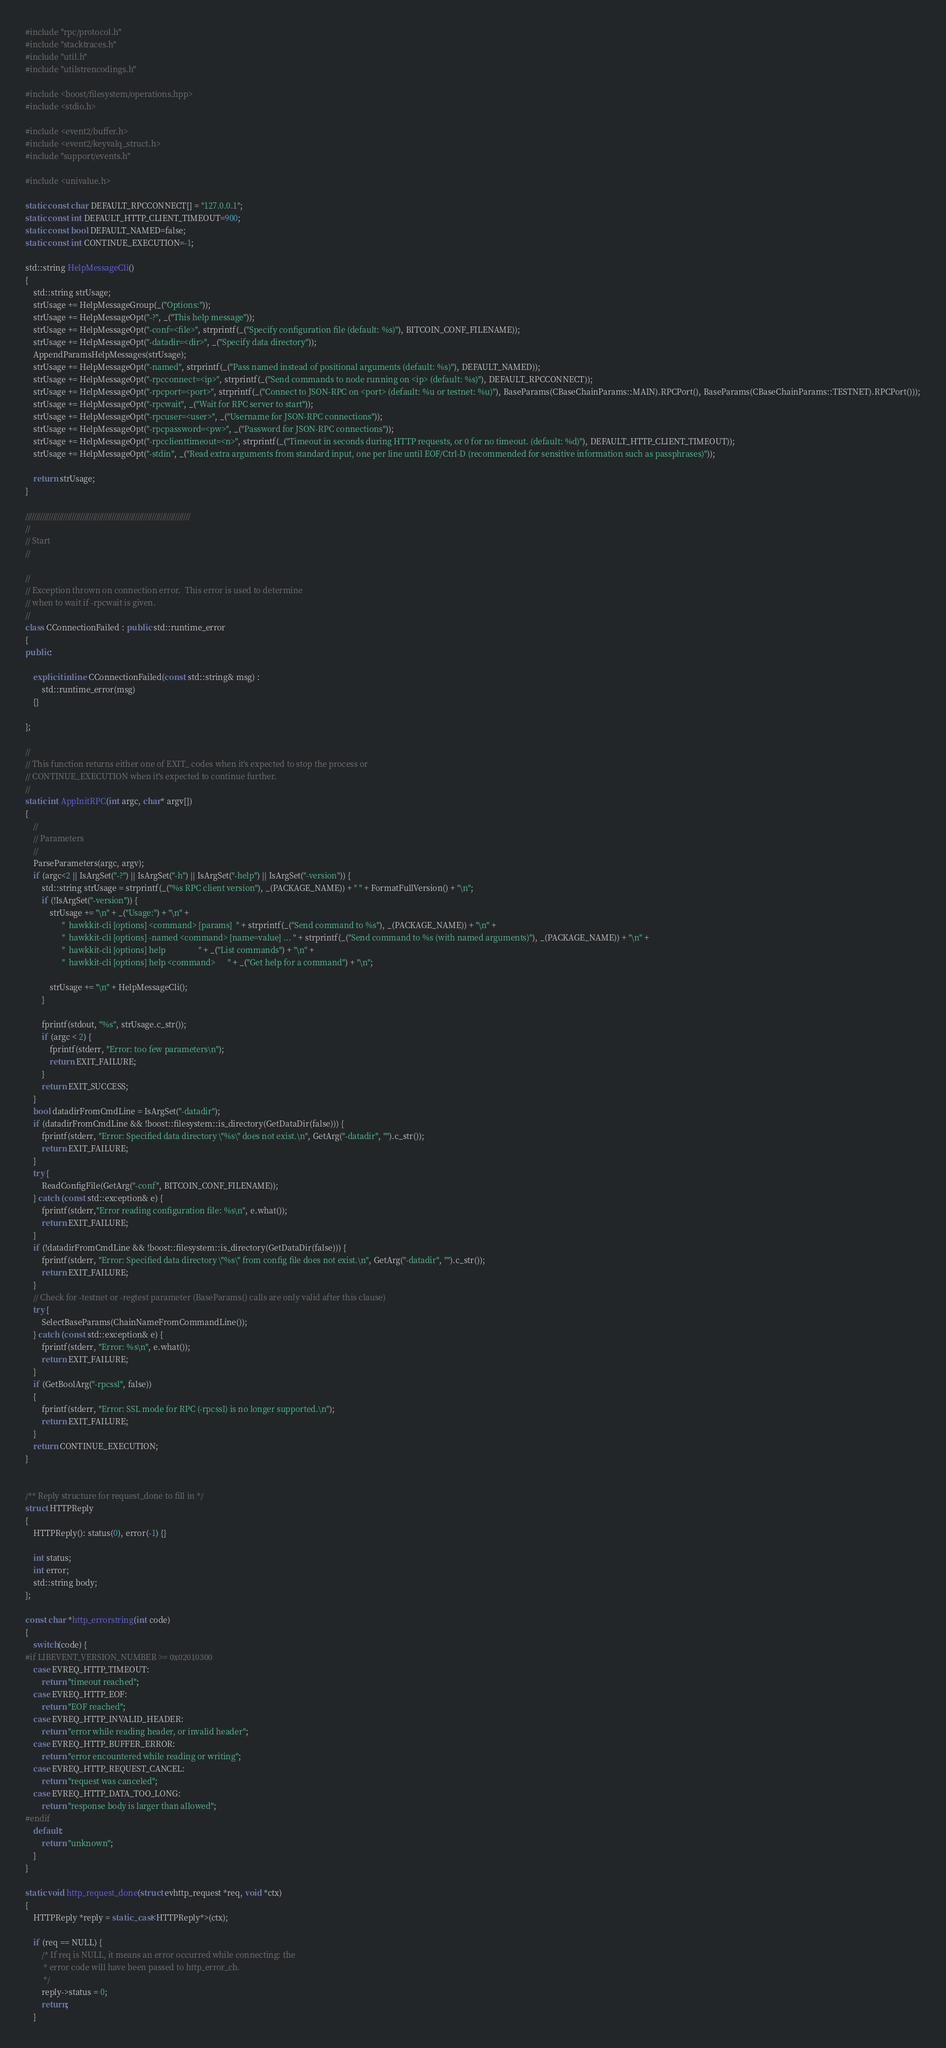<code> <loc_0><loc_0><loc_500><loc_500><_C++_>#include "rpc/protocol.h"
#include "stacktraces.h"
#include "util.h"
#include "utilstrencodings.h"

#include <boost/filesystem/operations.hpp>
#include <stdio.h>

#include <event2/buffer.h>
#include <event2/keyvalq_struct.h>
#include "support/events.h"

#include <univalue.h>

static const char DEFAULT_RPCCONNECT[] = "127.0.0.1";
static const int DEFAULT_HTTP_CLIENT_TIMEOUT=900;
static const bool DEFAULT_NAMED=false;
static const int CONTINUE_EXECUTION=-1;

std::string HelpMessageCli()
{
    std::string strUsage;
    strUsage += HelpMessageGroup(_("Options:"));
    strUsage += HelpMessageOpt("-?", _("This help message"));
    strUsage += HelpMessageOpt("-conf=<file>", strprintf(_("Specify configuration file (default: %s)"), BITCOIN_CONF_FILENAME));
    strUsage += HelpMessageOpt("-datadir=<dir>", _("Specify data directory"));
    AppendParamsHelpMessages(strUsage);
    strUsage += HelpMessageOpt("-named", strprintf(_("Pass named instead of positional arguments (default: %s)"), DEFAULT_NAMED));
    strUsage += HelpMessageOpt("-rpcconnect=<ip>", strprintf(_("Send commands to node running on <ip> (default: %s)"), DEFAULT_RPCCONNECT));
    strUsage += HelpMessageOpt("-rpcport=<port>", strprintf(_("Connect to JSON-RPC on <port> (default: %u or testnet: %u)"), BaseParams(CBaseChainParams::MAIN).RPCPort(), BaseParams(CBaseChainParams::TESTNET).RPCPort()));
    strUsage += HelpMessageOpt("-rpcwait", _("Wait for RPC server to start"));
    strUsage += HelpMessageOpt("-rpcuser=<user>", _("Username for JSON-RPC connections"));
    strUsage += HelpMessageOpt("-rpcpassword=<pw>", _("Password for JSON-RPC connections"));
    strUsage += HelpMessageOpt("-rpcclienttimeout=<n>", strprintf(_("Timeout in seconds during HTTP requests, or 0 for no timeout. (default: %d)"), DEFAULT_HTTP_CLIENT_TIMEOUT));
    strUsage += HelpMessageOpt("-stdin", _("Read extra arguments from standard input, one per line until EOF/Ctrl-D (recommended for sensitive information such as passphrases)"));

    return strUsage;
}

//////////////////////////////////////////////////////////////////////////////
//
// Start
//

//
// Exception thrown on connection error.  This error is used to determine
// when to wait if -rpcwait is given.
//
class CConnectionFailed : public std::runtime_error
{
public:

    explicit inline CConnectionFailed(const std::string& msg) :
        std::runtime_error(msg)
    {}

};

//
// This function returns either one of EXIT_ codes when it's expected to stop the process or
// CONTINUE_EXECUTION when it's expected to continue further.
//
static int AppInitRPC(int argc, char* argv[])
{
    //
    // Parameters
    //
    ParseParameters(argc, argv);
    if (argc<2 || IsArgSet("-?") || IsArgSet("-h") || IsArgSet("-help") || IsArgSet("-version")) {
        std::string strUsage = strprintf(_("%s RPC client version"), _(PACKAGE_NAME)) + " " + FormatFullVersion() + "\n";
        if (!IsArgSet("-version")) {
            strUsage += "\n" + _("Usage:") + "\n" +
                  "  hawkkit-cli [options] <command> [params]  " + strprintf(_("Send command to %s"), _(PACKAGE_NAME)) + "\n" +
                  "  hawkkit-cli [options] -named <command> [name=value] ... " + strprintf(_("Send command to %s (with named arguments)"), _(PACKAGE_NAME)) + "\n" +
                  "  hawkkit-cli [options] help                " + _("List commands") + "\n" +
                  "  hawkkit-cli [options] help <command>      " + _("Get help for a command") + "\n";

            strUsage += "\n" + HelpMessageCli();
        }

        fprintf(stdout, "%s", strUsage.c_str());
        if (argc < 2) {
            fprintf(stderr, "Error: too few parameters\n");
            return EXIT_FAILURE;
        }
        return EXIT_SUCCESS;
    }
    bool datadirFromCmdLine = IsArgSet("-datadir");
    if (datadirFromCmdLine && !boost::filesystem::is_directory(GetDataDir(false))) {
        fprintf(stderr, "Error: Specified data directory \"%s\" does not exist.\n", GetArg("-datadir", "").c_str());
        return EXIT_FAILURE;
    }
    try {
        ReadConfigFile(GetArg("-conf", BITCOIN_CONF_FILENAME));
    } catch (const std::exception& e) {
        fprintf(stderr,"Error reading configuration file: %s\n", e.what());
        return EXIT_FAILURE;
    }
    if (!datadirFromCmdLine && !boost::filesystem::is_directory(GetDataDir(false))) {
        fprintf(stderr, "Error: Specified data directory \"%s\" from config file does not exist.\n", GetArg("-datadir", "").c_str());
        return EXIT_FAILURE;
    }
    // Check for -testnet or -regtest parameter (BaseParams() calls are only valid after this clause)
    try {
        SelectBaseParams(ChainNameFromCommandLine());
    } catch (const std::exception& e) {
        fprintf(stderr, "Error: %s\n", e.what());
        return EXIT_FAILURE;
    }
    if (GetBoolArg("-rpcssl", false))
    {
        fprintf(stderr, "Error: SSL mode for RPC (-rpcssl) is no longer supported.\n");
        return EXIT_FAILURE;
    }
    return CONTINUE_EXECUTION;
}


/** Reply structure for request_done to fill in */
struct HTTPReply
{
    HTTPReply(): status(0), error(-1) {}

    int status;
    int error;
    std::string body;
};

const char *http_errorstring(int code)
{
    switch(code) {
#if LIBEVENT_VERSION_NUMBER >= 0x02010300
    case EVREQ_HTTP_TIMEOUT:
        return "timeout reached";
    case EVREQ_HTTP_EOF:
        return "EOF reached";
    case EVREQ_HTTP_INVALID_HEADER:
        return "error while reading header, or invalid header";
    case EVREQ_HTTP_BUFFER_ERROR:
        return "error encountered while reading or writing";
    case EVREQ_HTTP_REQUEST_CANCEL:
        return "request was canceled";
    case EVREQ_HTTP_DATA_TOO_LONG:
        return "response body is larger than allowed";
#endif
    default:
        return "unknown";
    }
}

static void http_request_done(struct evhttp_request *req, void *ctx)
{
    HTTPReply *reply = static_cast<HTTPReply*>(ctx);

    if (req == NULL) {
        /* If req is NULL, it means an error occurred while connecting: the
         * error code will have been passed to http_error_cb.
         */
        reply->status = 0;
        return;
    }
</code> 